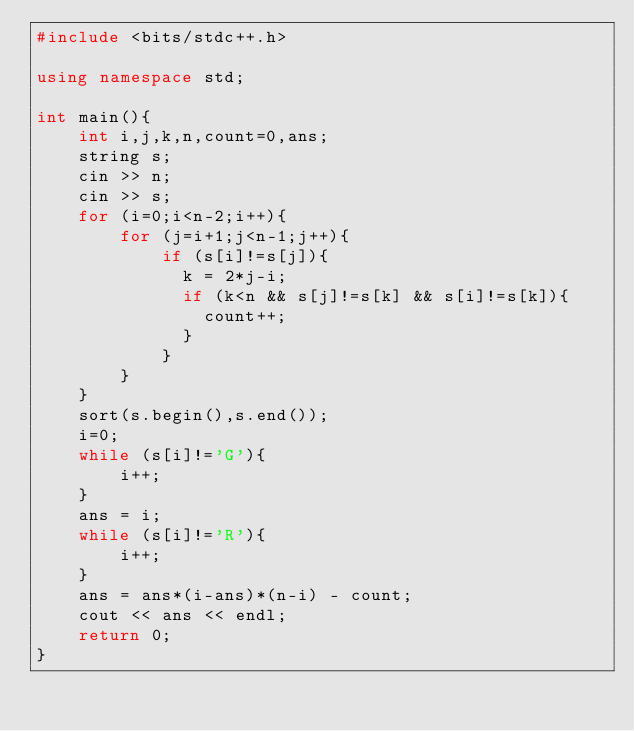Convert code to text. <code><loc_0><loc_0><loc_500><loc_500><_C++_>#include <bits/stdc++.h>

using namespace std;

int main(){
  	int i,j,k,n,count=0,ans;
  	string s;
  	cin >> n;
  	cin >> s;
  	for (i=0;i<n-2;i++){
    	for (j=i+1;j<n-1;j++){
          	if (s[i]!=s[j]){
              k = 2*j-i;
              if (k<n && s[j]!=s[k] && s[i]!=s[k]){
              	count++;
              }
            }
        }
    }
  	sort(s.begin(),s.end());
  	i=0;
  	while (s[i]!='G'){
    	i++;
    }
  	ans = i;
	while (s[i]!='R'){
    	i++;
    }
  	ans = ans*(i-ans)*(n-i) - count;
  	cout << ans << endl;
	return 0;
}</code> 